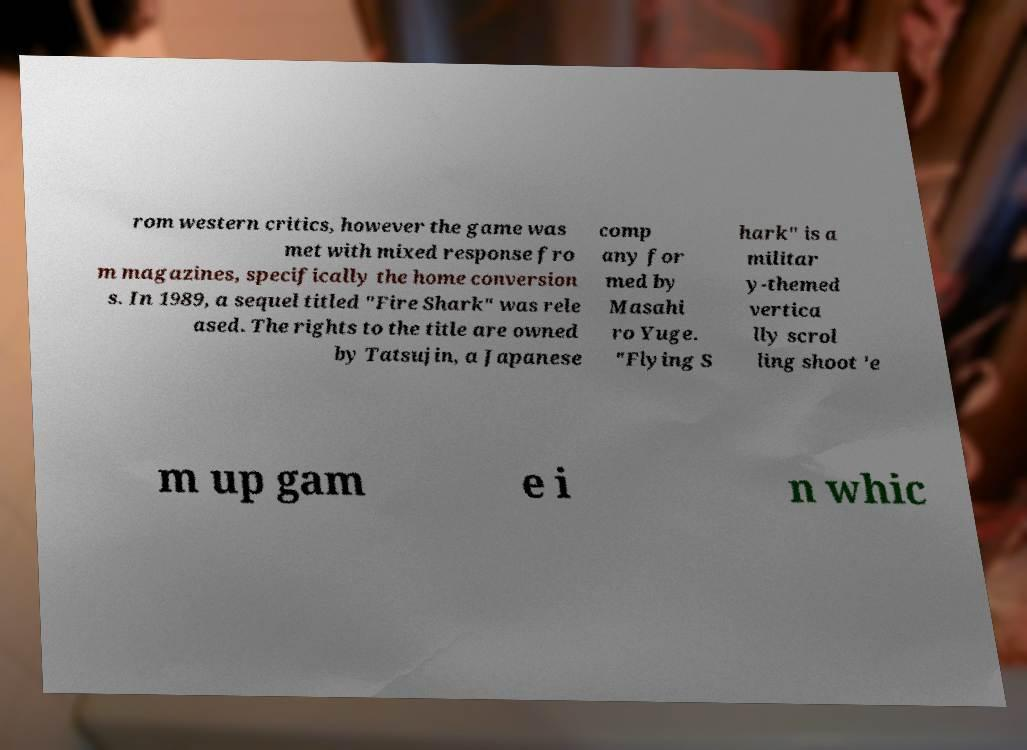Could you assist in decoding the text presented in this image and type it out clearly? rom western critics, however the game was met with mixed response fro m magazines, specifically the home conversion s. In 1989, a sequel titled "Fire Shark" was rele ased. The rights to the title are owned by Tatsujin, a Japanese comp any for med by Masahi ro Yuge. "Flying S hark" is a militar y-themed vertica lly scrol ling shoot 'e m up gam e i n whic 